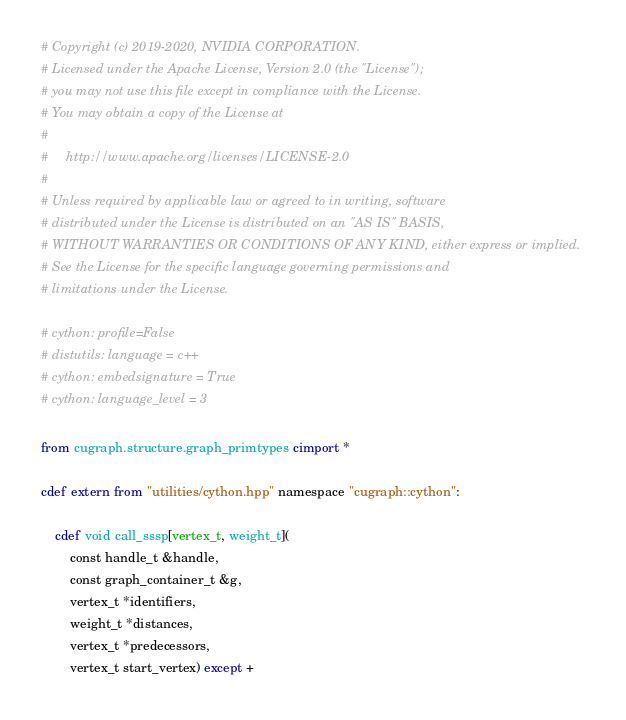<code> <loc_0><loc_0><loc_500><loc_500><_Cython_># Copyright (c) 2019-2020, NVIDIA CORPORATION.
# Licensed under the Apache License, Version 2.0 (the "License");
# you may not use this file except in compliance with the License.
# You may obtain a copy of the License at
#
#     http://www.apache.org/licenses/LICENSE-2.0
#
# Unless required by applicable law or agreed to in writing, software
# distributed under the License is distributed on an "AS IS" BASIS,
# WITHOUT WARRANTIES OR CONDITIONS OF ANY KIND, either express or implied.
# See the License for the specific language governing permissions and
# limitations under the License.

# cython: profile=False
# distutils: language = c++
# cython: embedsignature = True
# cython: language_level = 3

from cugraph.structure.graph_primtypes cimport *

cdef extern from "utilities/cython.hpp" namespace "cugraph::cython":

    cdef void call_sssp[vertex_t, weight_t](
        const handle_t &handle,
        const graph_container_t &g,
        vertex_t *identifiers,
        weight_t *distances,
        vertex_t *predecessors,
        vertex_t start_vertex) except +
</code> 